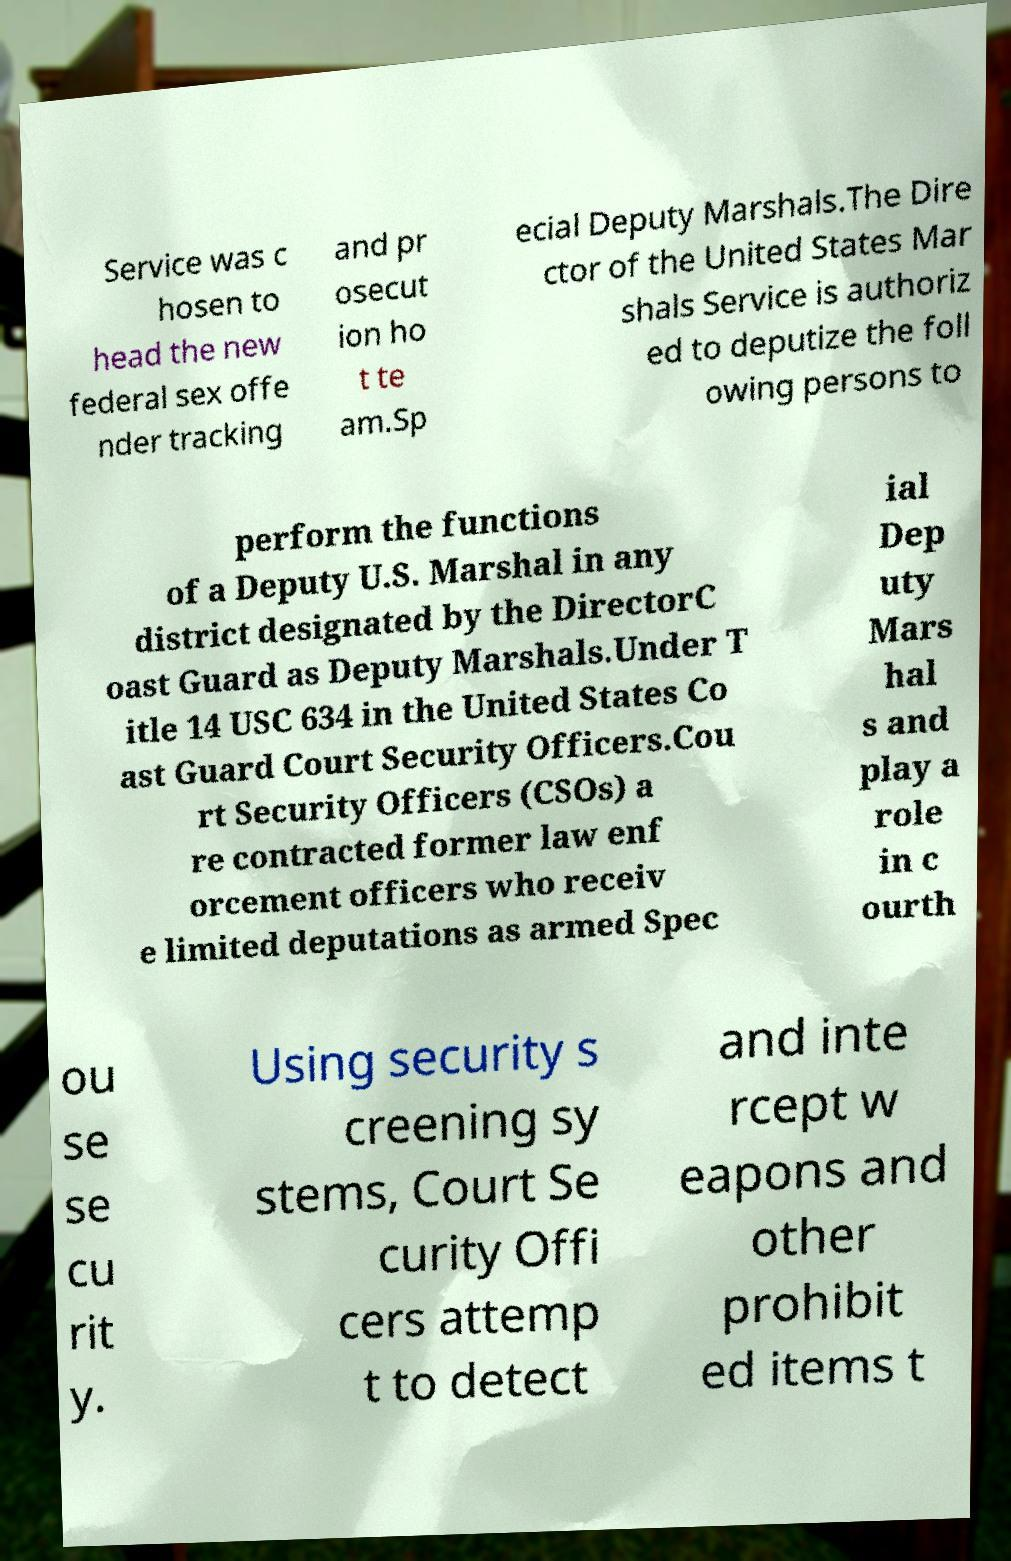Could you extract and type out the text from this image? Service was c hosen to head the new federal sex offe nder tracking and pr osecut ion ho t te am.Sp ecial Deputy Marshals.The Dire ctor of the United States Mar shals Service is authoriz ed to deputize the foll owing persons to perform the functions of a Deputy U.S. Marshal in any district designated by the DirectorC oast Guard as Deputy Marshals.Under T itle 14 USC 634 in the United States Co ast Guard Court Security Officers.Cou rt Security Officers (CSOs) a re contracted former law enf orcement officers who receiv e limited deputations as armed Spec ial Dep uty Mars hal s and play a role in c ourth ou se se cu rit y. Using security s creening sy stems, Court Se curity Offi cers attemp t to detect and inte rcept w eapons and other prohibit ed items t 